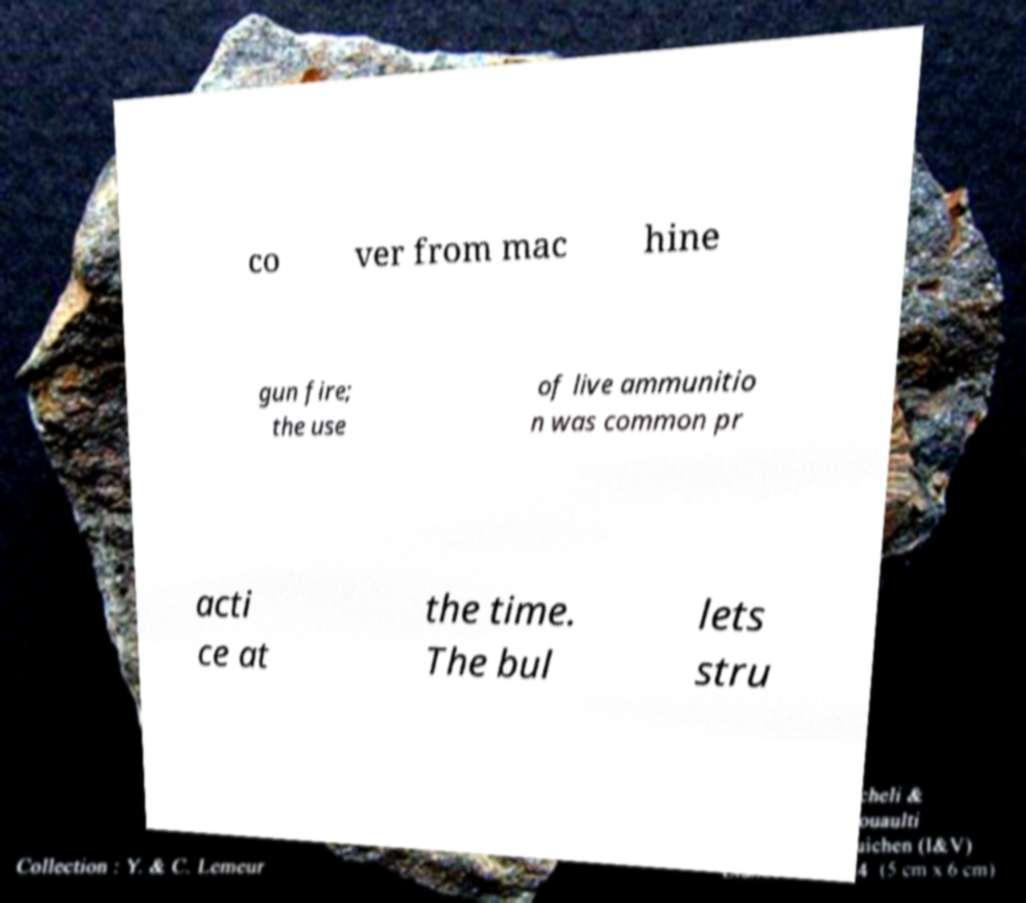Could you assist in decoding the text presented in this image and type it out clearly? co ver from mac hine gun fire; the use of live ammunitio n was common pr acti ce at the time. The bul lets stru 